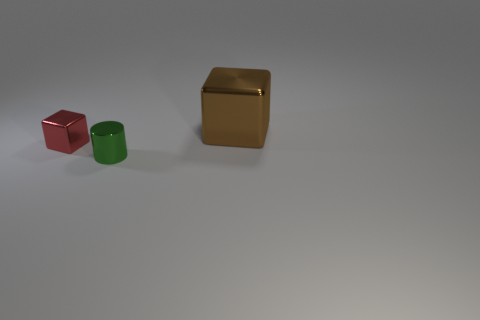Add 1 green objects. How many objects exist? 4 Subtract all blocks. How many objects are left? 1 Add 2 big metallic cubes. How many big metallic cubes are left? 3 Add 2 cyan spheres. How many cyan spheres exist? 2 Subtract 0 yellow blocks. How many objects are left? 3 Subtract all small objects. Subtract all green spheres. How many objects are left? 1 